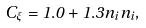<formula> <loc_0><loc_0><loc_500><loc_500>C _ { \xi } = 1 . 0 + 1 . 3 n _ { i } n _ { i } ,</formula> 